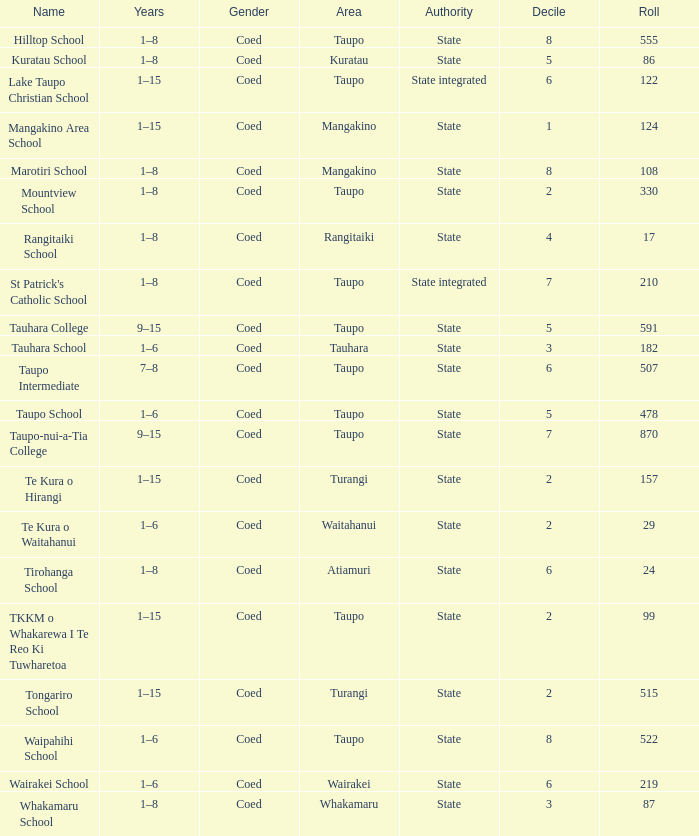Where is the school with state authority that has a roll of more than 157 students? Taupo, Taupo, Taupo, Tauhara, Taupo, Taupo, Taupo, Turangi, Taupo, Wairakei. 